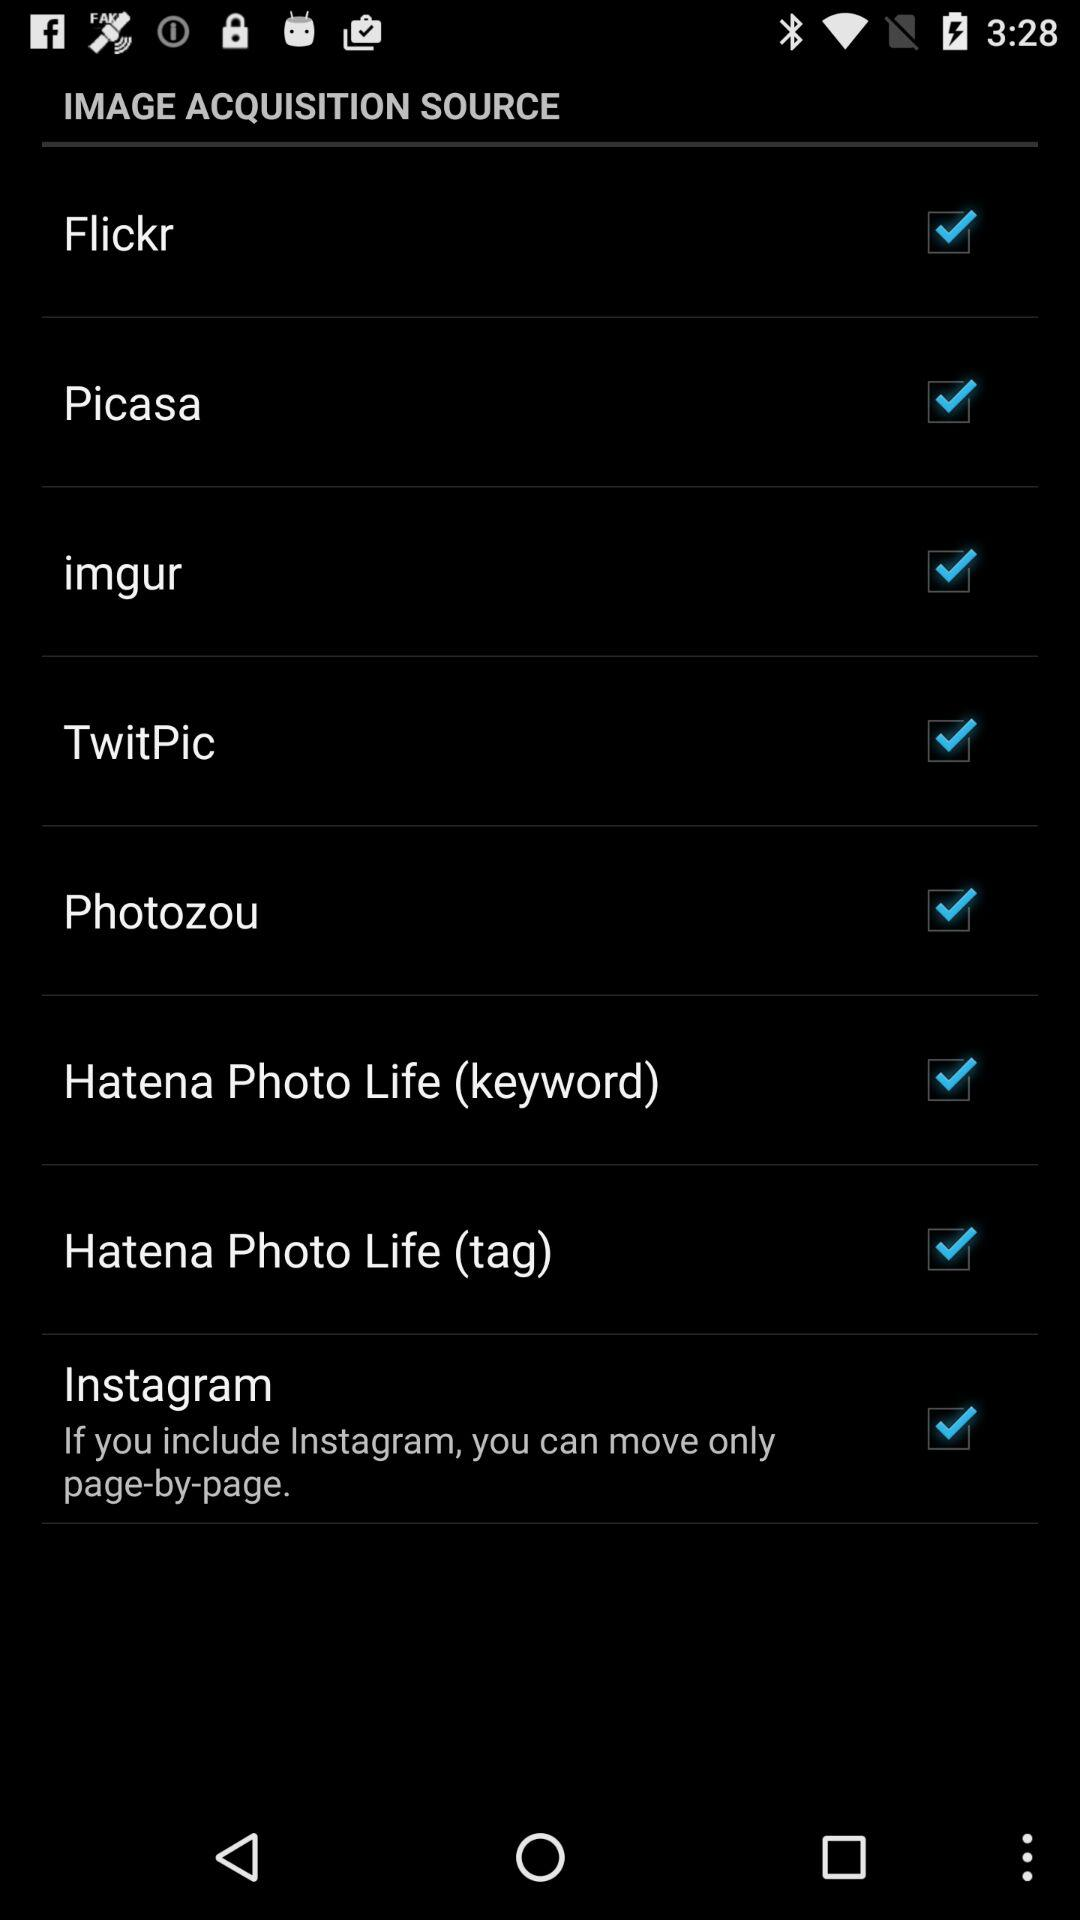What is the status of "imgur"? The status of "imgur" is "on". 